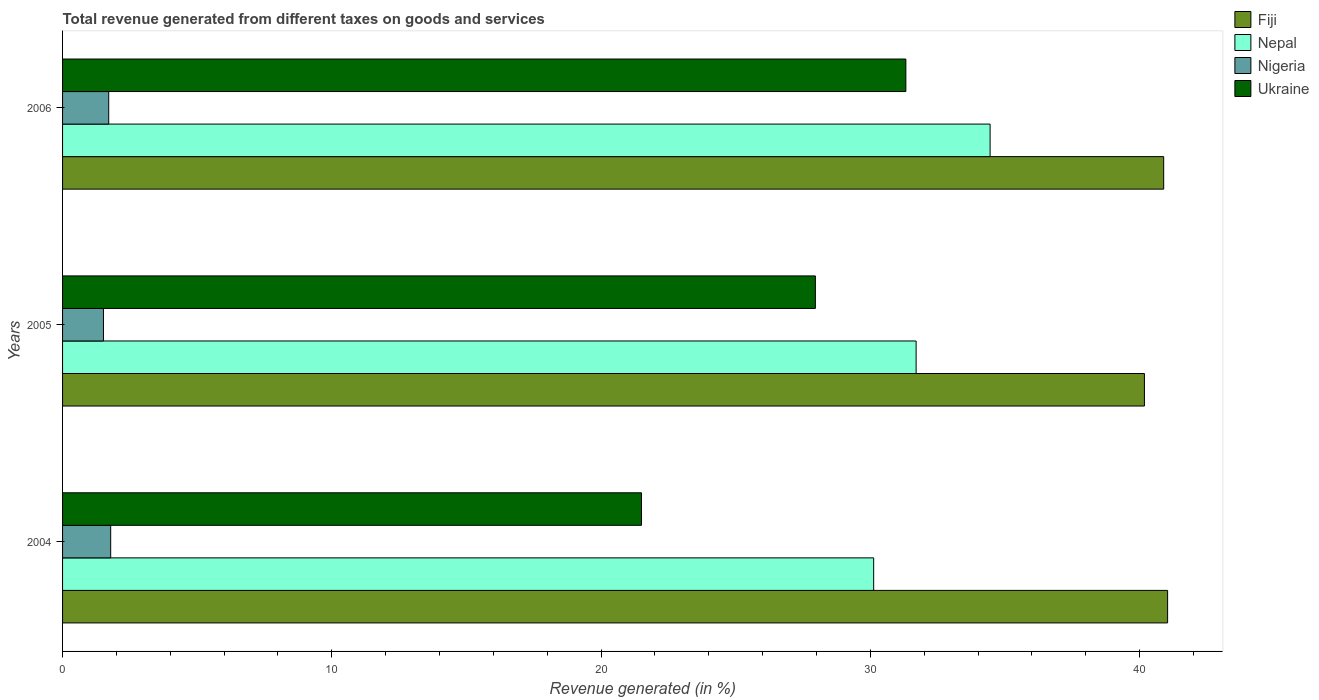How many different coloured bars are there?
Keep it short and to the point. 4. How many groups of bars are there?
Offer a terse response. 3. Are the number of bars per tick equal to the number of legend labels?
Make the answer very short. Yes. Are the number of bars on each tick of the Y-axis equal?
Your answer should be very brief. Yes. How many bars are there on the 1st tick from the bottom?
Your answer should be very brief. 4. What is the label of the 3rd group of bars from the top?
Your answer should be compact. 2004. In how many cases, is the number of bars for a given year not equal to the number of legend labels?
Your answer should be compact. 0. What is the total revenue generated in Nigeria in 2006?
Keep it short and to the point. 1.71. Across all years, what is the maximum total revenue generated in Nepal?
Your answer should be very brief. 34.45. Across all years, what is the minimum total revenue generated in Nigeria?
Your response must be concise. 1.52. What is the total total revenue generated in Ukraine in the graph?
Provide a short and direct response. 80.77. What is the difference between the total revenue generated in Fiji in 2004 and that in 2005?
Ensure brevity in your answer.  0.86. What is the difference between the total revenue generated in Nigeria in 2004 and the total revenue generated in Fiji in 2005?
Offer a very short reply. -38.39. What is the average total revenue generated in Nigeria per year?
Keep it short and to the point. 1.67. In the year 2004, what is the difference between the total revenue generated in Ukraine and total revenue generated in Fiji?
Offer a very short reply. -19.54. In how many years, is the total revenue generated in Ukraine greater than 32 %?
Ensure brevity in your answer.  0. What is the ratio of the total revenue generated in Nigeria in 2004 to that in 2005?
Ensure brevity in your answer.  1.18. Is the total revenue generated in Ukraine in 2004 less than that in 2005?
Make the answer very short. Yes. What is the difference between the highest and the second highest total revenue generated in Nepal?
Provide a short and direct response. 2.75. What is the difference between the highest and the lowest total revenue generated in Fiji?
Your response must be concise. 0.86. Is the sum of the total revenue generated in Nigeria in 2004 and 2005 greater than the maximum total revenue generated in Nepal across all years?
Your answer should be compact. No. What does the 4th bar from the top in 2006 represents?
Provide a succinct answer. Fiji. What does the 4th bar from the bottom in 2006 represents?
Your response must be concise. Ukraine. Is it the case that in every year, the sum of the total revenue generated in Ukraine and total revenue generated in Nepal is greater than the total revenue generated in Nigeria?
Ensure brevity in your answer.  Yes. How many years are there in the graph?
Provide a succinct answer. 3. What is the difference between two consecutive major ticks on the X-axis?
Ensure brevity in your answer.  10. How many legend labels are there?
Your answer should be compact. 4. How are the legend labels stacked?
Your answer should be very brief. Vertical. What is the title of the graph?
Your answer should be very brief. Total revenue generated from different taxes on goods and services. Does "High income: OECD" appear as one of the legend labels in the graph?
Provide a short and direct response. No. What is the label or title of the X-axis?
Make the answer very short. Revenue generated (in %). What is the Revenue generated (in %) in Fiji in 2004?
Your answer should be compact. 41.04. What is the Revenue generated (in %) in Nepal in 2004?
Give a very brief answer. 30.12. What is the Revenue generated (in %) of Nigeria in 2004?
Offer a very short reply. 1.79. What is the Revenue generated (in %) in Ukraine in 2004?
Give a very brief answer. 21.5. What is the Revenue generated (in %) of Fiji in 2005?
Your answer should be compact. 40.18. What is the Revenue generated (in %) in Nepal in 2005?
Ensure brevity in your answer.  31.7. What is the Revenue generated (in %) of Nigeria in 2005?
Make the answer very short. 1.52. What is the Revenue generated (in %) of Ukraine in 2005?
Keep it short and to the point. 27.96. What is the Revenue generated (in %) of Fiji in 2006?
Give a very brief answer. 40.89. What is the Revenue generated (in %) of Nepal in 2006?
Keep it short and to the point. 34.45. What is the Revenue generated (in %) of Nigeria in 2006?
Your response must be concise. 1.71. What is the Revenue generated (in %) of Ukraine in 2006?
Your response must be concise. 31.32. Across all years, what is the maximum Revenue generated (in %) of Fiji?
Offer a terse response. 41.04. Across all years, what is the maximum Revenue generated (in %) in Nepal?
Provide a short and direct response. 34.45. Across all years, what is the maximum Revenue generated (in %) of Nigeria?
Ensure brevity in your answer.  1.79. Across all years, what is the maximum Revenue generated (in %) of Ukraine?
Provide a short and direct response. 31.32. Across all years, what is the minimum Revenue generated (in %) of Fiji?
Keep it short and to the point. 40.18. Across all years, what is the minimum Revenue generated (in %) in Nepal?
Give a very brief answer. 30.12. Across all years, what is the minimum Revenue generated (in %) in Nigeria?
Offer a very short reply. 1.52. Across all years, what is the minimum Revenue generated (in %) in Ukraine?
Your response must be concise. 21.5. What is the total Revenue generated (in %) of Fiji in the graph?
Provide a short and direct response. 122.11. What is the total Revenue generated (in %) of Nepal in the graph?
Your response must be concise. 96.27. What is the total Revenue generated (in %) in Nigeria in the graph?
Your answer should be compact. 5.02. What is the total Revenue generated (in %) of Ukraine in the graph?
Offer a very short reply. 80.77. What is the difference between the Revenue generated (in %) in Fiji in 2004 and that in 2005?
Provide a succinct answer. 0.86. What is the difference between the Revenue generated (in %) in Nepal in 2004 and that in 2005?
Give a very brief answer. -1.58. What is the difference between the Revenue generated (in %) in Nigeria in 2004 and that in 2005?
Provide a short and direct response. 0.27. What is the difference between the Revenue generated (in %) of Ukraine in 2004 and that in 2005?
Offer a very short reply. -6.46. What is the difference between the Revenue generated (in %) in Fiji in 2004 and that in 2006?
Your answer should be compact. 0.15. What is the difference between the Revenue generated (in %) in Nepal in 2004 and that in 2006?
Give a very brief answer. -4.32. What is the difference between the Revenue generated (in %) of Nigeria in 2004 and that in 2006?
Give a very brief answer. 0.07. What is the difference between the Revenue generated (in %) in Ukraine in 2004 and that in 2006?
Ensure brevity in your answer.  -9.82. What is the difference between the Revenue generated (in %) of Fiji in 2005 and that in 2006?
Offer a very short reply. -0.72. What is the difference between the Revenue generated (in %) of Nepal in 2005 and that in 2006?
Make the answer very short. -2.75. What is the difference between the Revenue generated (in %) of Nigeria in 2005 and that in 2006?
Ensure brevity in your answer.  -0.2. What is the difference between the Revenue generated (in %) in Ukraine in 2005 and that in 2006?
Give a very brief answer. -3.36. What is the difference between the Revenue generated (in %) of Fiji in 2004 and the Revenue generated (in %) of Nepal in 2005?
Make the answer very short. 9.34. What is the difference between the Revenue generated (in %) in Fiji in 2004 and the Revenue generated (in %) in Nigeria in 2005?
Your answer should be very brief. 39.52. What is the difference between the Revenue generated (in %) in Fiji in 2004 and the Revenue generated (in %) in Ukraine in 2005?
Provide a succinct answer. 13.08. What is the difference between the Revenue generated (in %) in Nepal in 2004 and the Revenue generated (in %) in Nigeria in 2005?
Your response must be concise. 28.6. What is the difference between the Revenue generated (in %) in Nepal in 2004 and the Revenue generated (in %) in Ukraine in 2005?
Provide a short and direct response. 2.17. What is the difference between the Revenue generated (in %) of Nigeria in 2004 and the Revenue generated (in %) of Ukraine in 2005?
Your response must be concise. -26.17. What is the difference between the Revenue generated (in %) of Fiji in 2004 and the Revenue generated (in %) of Nepal in 2006?
Offer a terse response. 6.59. What is the difference between the Revenue generated (in %) in Fiji in 2004 and the Revenue generated (in %) in Nigeria in 2006?
Offer a very short reply. 39.32. What is the difference between the Revenue generated (in %) in Fiji in 2004 and the Revenue generated (in %) in Ukraine in 2006?
Provide a succinct answer. 9.72. What is the difference between the Revenue generated (in %) in Nepal in 2004 and the Revenue generated (in %) in Nigeria in 2006?
Keep it short and to the point. 28.41. What is the difference between the Revenue generated (in %) in Nepal in 2004 and the Revenue generated (in %) in Ukraine in 2006?
Your answer should be compact. -1.19. What is the difference between the Revenue generated (in %) in Nigeria in 2004 and the Revenue generated (in %) in Ukraine in 2006?
Keep it short and to the point. -29.53. What is the difference between the Revenue generated (in %) of Fiji in 2005 and the Revenue generated (in %) of Nepal in 2006?
Give a very brief answer. 5.73. What is the difference between the Revenue generated (in %) of Fiji in 2005 and the Revenue generated (in %) of Nigeria in 2006?
Ensure brevity in your answer.  38.46. What is the difference between the Revenue generated (in %) in Fiji in 2005 and the Revenue generated (in %) in Ukraine in 2006?
Give a very brief answer. 8.86. What is the difference between the Revenue generated (in %) in Nepal in 2005 and the Revenue generated (in %) in Nigeria in 2006?
Ensure brevity in your answer.  29.99. What is the difference between the Revenue generated (in %) of Nepal in 2005 and the Revenue generated (in %) of Ukraine in 2006?
Offer a terse response. 0.38. What is the difference between the Revenue generated (in %) of Nigeria in 2005 and the Revenue generated (in %) of Ukraine in 2006?
Give a very brief answer. -29.8. What is the average Revenue generated (in %) in Fiji per year?
Your response must be concise. 40.7. What is the average Revenue generated (in %) in Nepal per year?
Your response must be concise. 32.09. What is the average Revenue generated (in %) in Nigeria per year?
Your response must be concise. 1.67. What is the average Revenue generated (in %) in Ukraine per year?
Your answer should be very brief. 26.92. In the year 2004, what is the difference between the Revenue generated (in %) in Fiji and Revenue generated (in %) in Nepal?
Keep it short and to the point. 10.92. In the year 2004, what is the difference between the Revenue generated (in %) of Fiji and Revenue generated (in %) of Nigeria?
Offer a very short reply. 39.25. In the year 2004, what is the difference between the Revenue generated (in %) in Fiji and Revenue generated (in %) in Ukraine?
Offer a terse response. 19.54. In the year 2004, what is the difference between the Revenue generated (in %) of Nepal and Revenue generated (in %) of Nigeria?
Give a very brief answer. 28.34. In the year 2004, what is the difference between the Revenue generated (in %) in Nepal and Revenue generated (in %) in Ukraine?
Provide a short and direct response. 8.62. In the year 2004, what is the difference between the Revenue generated (in %) of Nigeria and Revenue generated (in %) of Ukraine?
Make the answer very short. -19.71. In the year 2005, what is the difference between the Revenue generated (in %) of Fiji and Revenue generated (in %) of Nepal?
Offer a very short reply. 8.48. In the year 2005, what is the difference between the Revenue generated (in %) in Fiji and Revenue generated (in %) in Nigeria?
Offer a very short reply. 38.66. In the year 2005, what is the difference between the Revenue generated (in %) of Fiji and Revenue generated (in %) of Ukraine?
Provide a succinct answer. 12.22. In the year 2005, what is the difference between the Revenue generated (in %) of Nepal and Revenue generated (in %) of Nigeria?
Provide a short and direct response. 30.18. In the year 2005, what is the difference between the Revenue generated (in %) in Nepal and Revenue generated (in %) in Ukraine?
Provide a succinct answer. 3.74. In the year 2005, what is the difference between the Revenue generated (in %) in Nigeria and Revenue generated (in %) in Ukraine?
Your answer should be very brief. -26.44. In the year 2006, what is the difference between the Revenue generated (in %) in Fiji and Revenue generated (in %) in Nepal?
Provide a succinct answer. 6.45. In the year 2006, what is the difference between the Revenue generated (in %) of Fiji and Revenue generated (in %) of Nigeria?
Make the answer very short. 39.18. In the year 2006, what is the difference between the Revenue generated (in %) of Fiji and Revenue generated (in %) of Ukraine?
Give a very brief answer. 9.58. In the year 2006, what is the difference between the Revenue generated (in %) of Nepal and Revenue generated (in %) of Nigeria?
Offer a very short reply. 32.73. In the year 2006, what is the difference between the Revenue generated (in %) in Nepal and Revenue generated (in %) in Ukraine?
Give a very brief answer. 3.13. In the year 2006, what is the difference between the Revenue generated (in %) of Nigeria and Revenue generated (in %) of Ukraine?
Provide a short and direct response. -29.6. What is the ratio of the Revenue generated (in %) of Fiji in 2004 to that in 2005?
Make the answer very short. 1.02. What is the ratio of the Revenue generated (in %) in Nepal in 2004 to that in 2005?
Make the answer very short. 0.95. What is the ratio of the Revenue generated (in %) of Nigeria in 2004 to that in 2005?
Give a very brief answer. 1.18. What is the ratio of the Revenue generated (in %) in Ukraine in 2004 to that in 2005?
Provide a succinct answer. 0.77. What is the ratio of the Revenue generated (in %) of Fiji in 2004 to that in 2006?
Make the answer very short. 1. What is the ratio of the Revenue generated (in %) of Nepal in 2004 to that in 2006?
Offer a very short reply. 0.87. What is the ratio of the Revenue generated (in %) of Nigeria in 2004 to that in 2006?
Your response must be concise. 1.04. What is the ratio of the Revenue generated (in %) of Ukraine in 2004 to that in 2006?
Your answer should be compact. 0.69. What is the ratio of the Revenue generated (in %) in Fiji in 2005 to that in 2006?
Make the answer very short. 0.98. What is the ratio of the Revenue generated (in %) in Nepal in 2005 to that in 2006?
Offer a terse response. 0.92. What is the ratio of the Revenue generated (in %) in Nigeria in 2005 to that in 2006?
Give a very brief answer. 0.89. What is the ratio of the Revenue generated (in %) of Ukraine in 2005 to that in 2006?
Make the answer very short. 0.89. What is the difference between the highest and the second highest Revenue generated (in %) of Fiji?
Your response must be concise. 0.15. What is the difference between the highest and the second highest Revenue generated (in %) in Nepal?
Give a very brief answer. 2.75. What is the difference between the highest and the second highest Revenue generated (in %) of Nigeria?
Make the answer very short. 0.07. What is the difference between the highest and the second highest Revenue generated (in %) of Ukraine?
Provide a short and direct response. 3.36. What is the difference between the highest and the lowest Revenue generated (in %) of Fiji?
Your response must be concise. 0.86. What is the difference between the highest and the lowest Revenue generated (in %) in Nepal?
Make the answer very short. 4.32. What is the difference between the highest and the lowest Revenue generated (in %) of Nigeria?
Offer a very short reply. 0.27. What is the difference between the highest and the lowest Revenue generated (in %) in Ukraine?
Your answer should be compact. 9.82. 